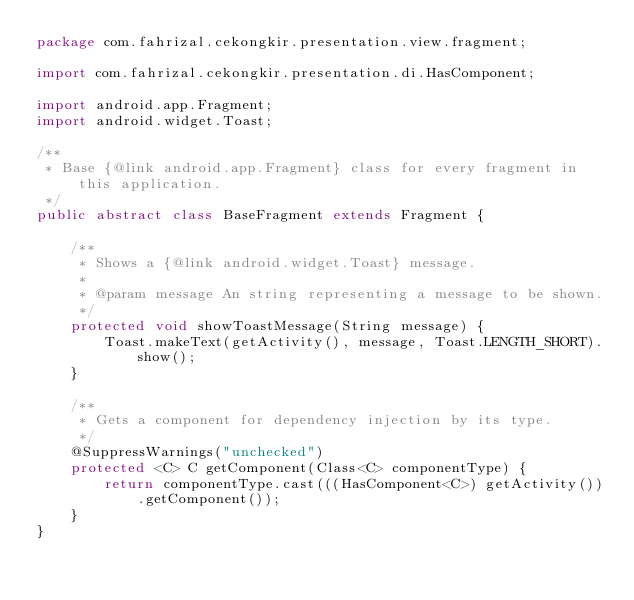Convert code to text. <code><loc_0><loc_0><loc_500><loc_500><_Java_>package com.fahrizal.cekongkir.presentation.view.fragment;

import com.fahrizal.cekongkir.presentation.di.HasComponent;

import android.app.Fragment;
import android.widget.Toast;

/**
 * Base {@link android.app.Fragment} class for every fragment in this application.
 */
public abstract class BaseFragment extends Fragment {

    /**
     * Shows a {@link android.widget.Toast} message.
     *
     * @param message An string representing a message to be shown.
     */
    protected void showToastMessage(String message) {
        Toast.makeText(getActivity(), message, Toast.LENGTH_SHORT).show();
    }

    /**
     * Gets a component for dependency injection by its type.
     */
    @SuppressWarnings("unchecked")
    protected <C> C getComponent(Class<C> componentType) {
        return componentType.cast(((HasComponent<C>) getActivity()).getComponent());
    }
}
</code> 